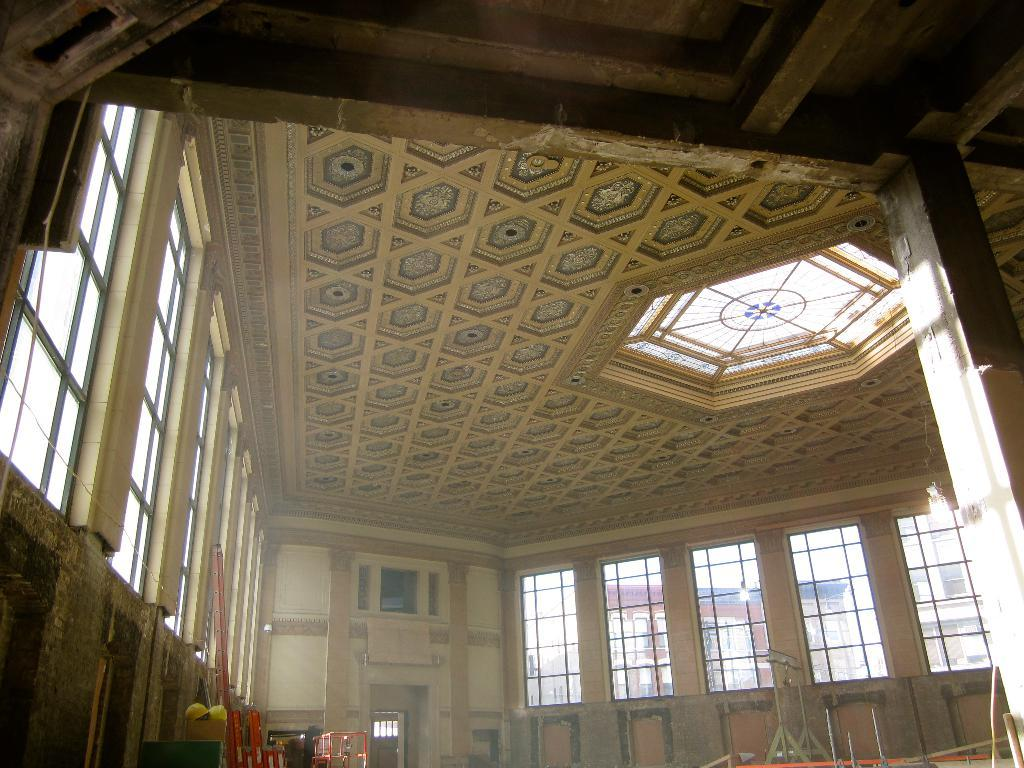What type of location is depicted in the image? The image shows the inside of a building. What architectural features can be seen in the building? There are windows and walls in the building. What can be found inside the building? There are objects placed inside the building. What type of food is being prepared by the partner in the image? There is no partner or food preparation visible in the image; it only shows the inside of a building with windows and walls. 